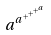Convert formula to latex. <formula><loc_0><loc_0><loc_500><loc_500>a ^ { a ^ { + ^ { + ^ { + ^ { a } } } } }</formula> 